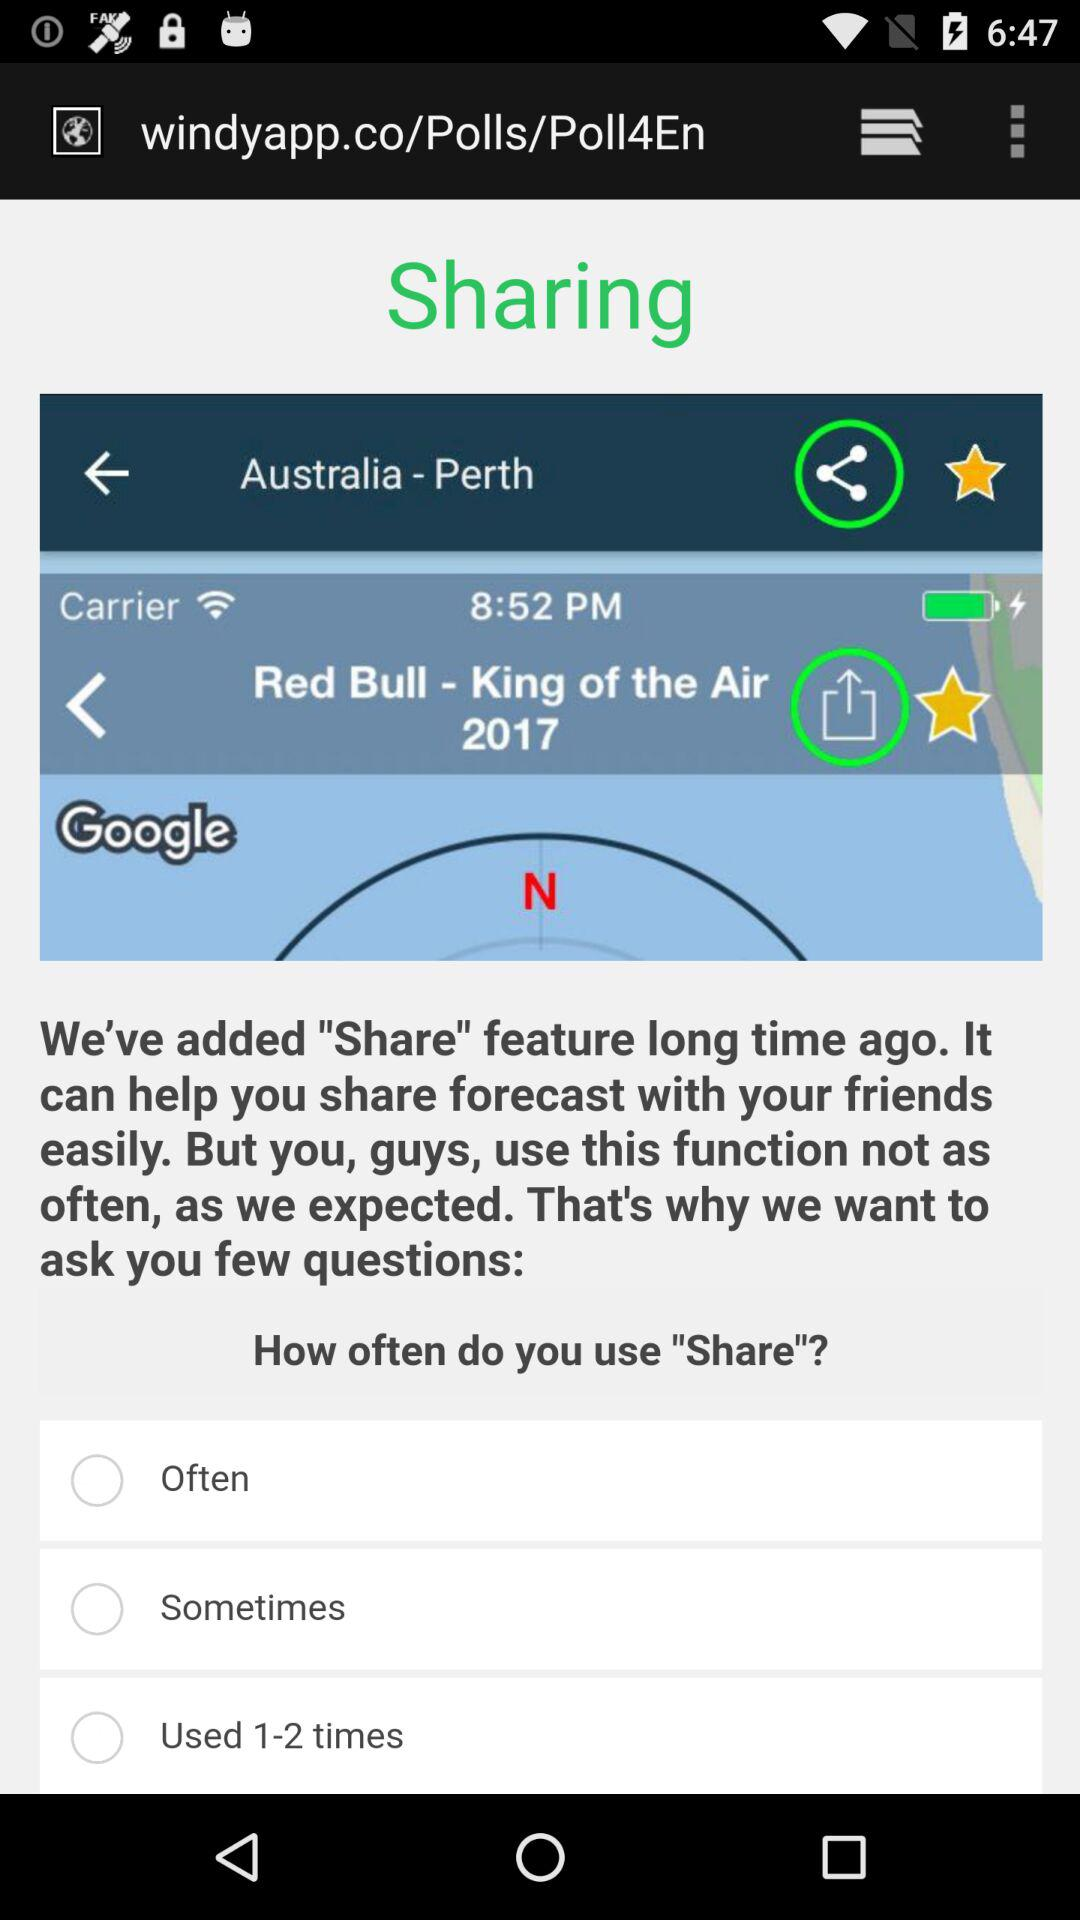What is the status of "Often"? The status is "off". 